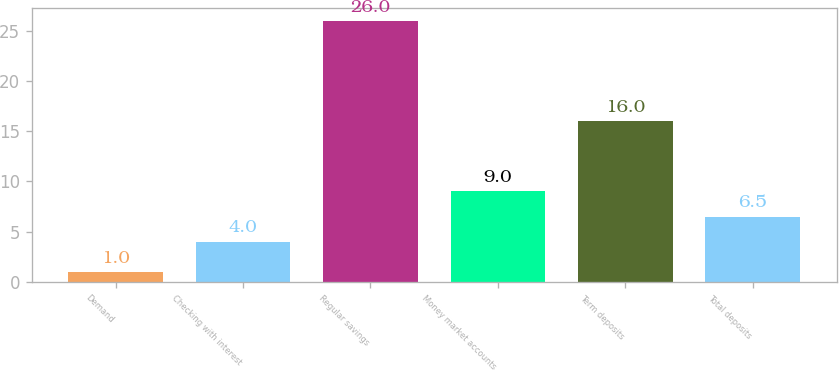<chart> <loc_0><loc_0><loc_500><loc_500><bar_chart><fcel>Demand<fcel>Checking with interest<fcel>Regular savings<fcel>Money market accounts<fcel>Term deposits<fcel>Total deposits<nl><fcel>1<fcel>4<fcel>26<fcel>9<fcel>16<fcel>6.5<nl></chart> 